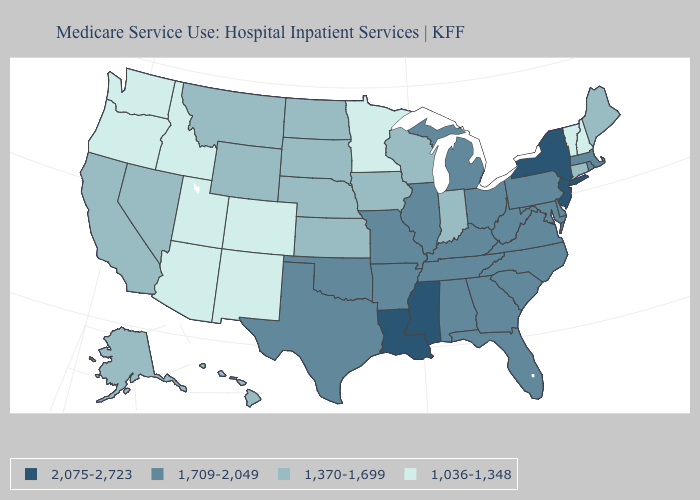What is the lowest value in the MidWest?
Be succinct. 1,036-1,348. What is the highest value in the USA?
Keep it brief. 2,075-2,723. Among the states that border Louisiana , does Mississippi have the highest value?
Give a very brief answer. Yes. Does the first symbol in the legend represent the smallest category?
Quick response, please. No. Is the legend a continuous bar?
Quick response, please. No. Is the legend a continuous bar?
Write a very short answer. No. What is the value of Minnesota?
Give a very brief answer. 1,036-1,348. Does Arkansas have a higher value than Alaska?
Concise answer only. Yes. Name the states that have a value in the range 2,075-2,723?
Short answer required. Louisiana, Mississippi, New Jersey, New York. Does the first symbol in the legend represent the smallest category?
Write a very short answer. No. Name the states that have a value in the range 2,075-2,723?
Answer briefly. Louisiana, Mississippi, New Jersey, New York. What is the value of Missouri?
Quick response, please. 1,709-2,049. Name the states that have a value in the range 2,075-2,723?
Keep it brief. Louisiana, Mississippi, New Jersey, New York. Does Louisiana have the lowest value in the South?
Short answer required. No. What is the value of Utah?
Keep it brief. 1,036-1,348. 